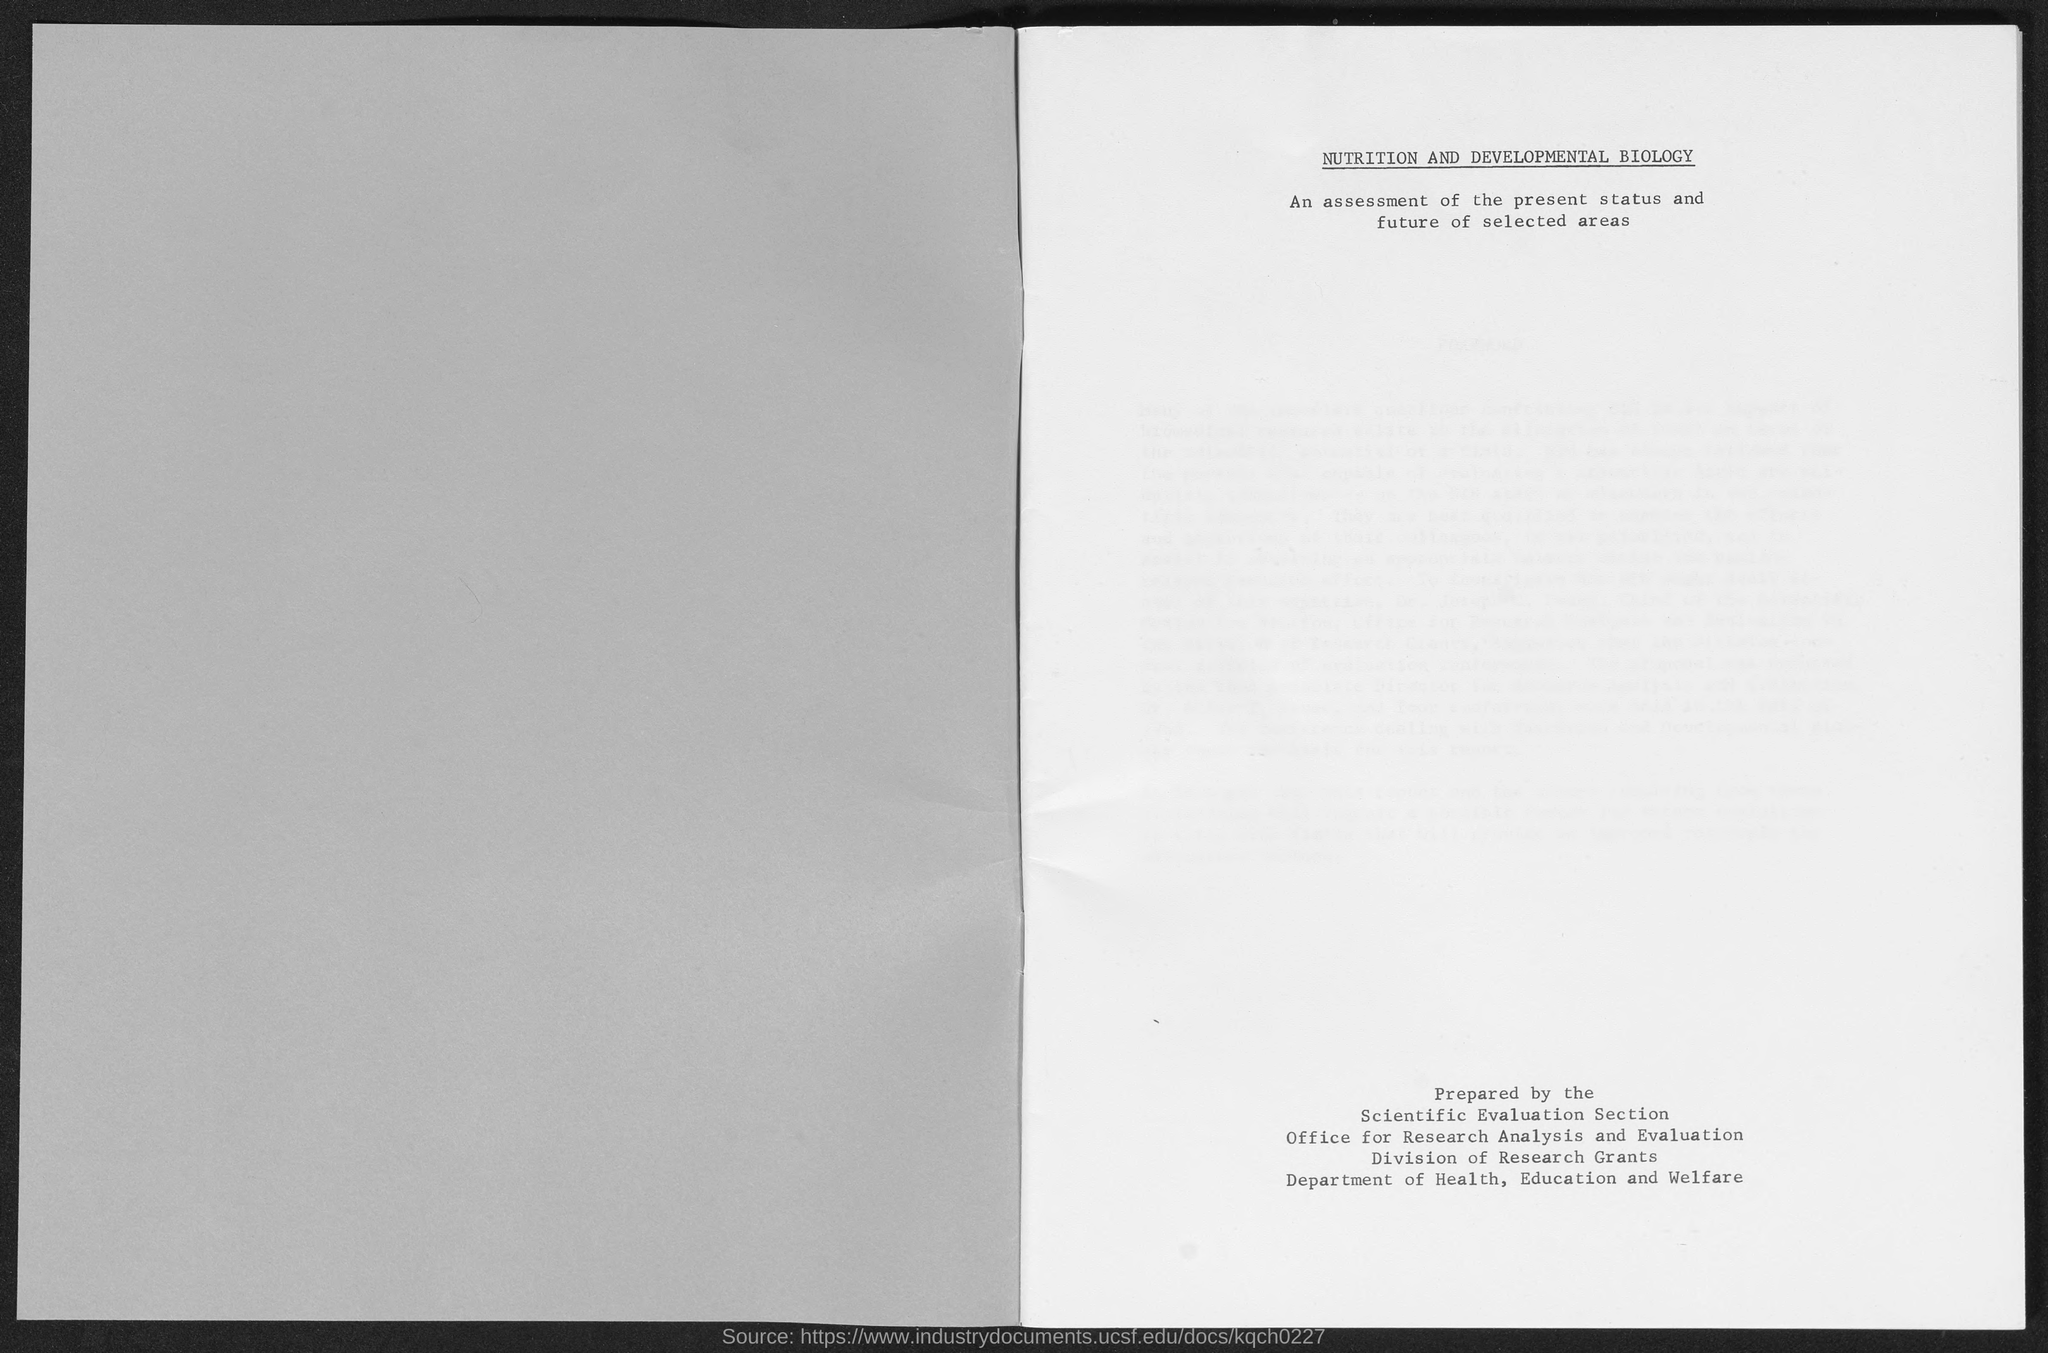Highlight a few significant elements in this photo. The title of the document is 'Nutrition and Developmental Biology.' 